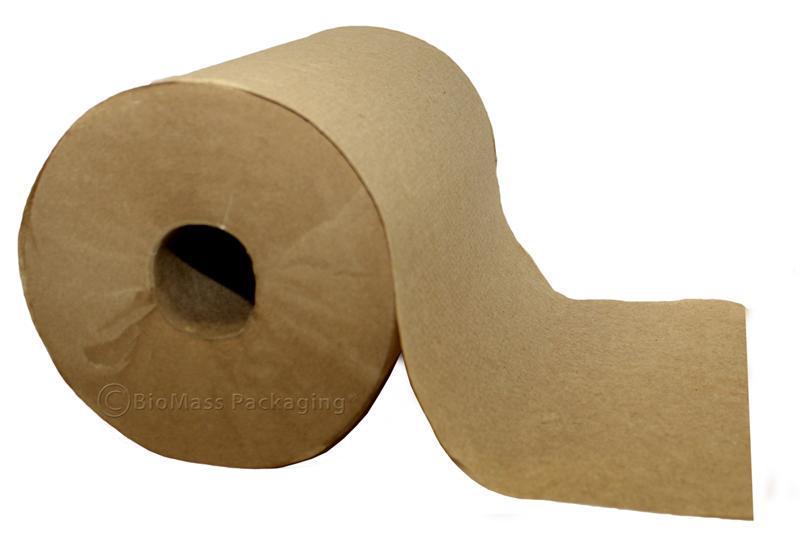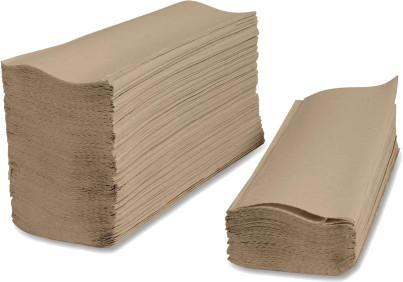The first image is the image on the left, the second image is the image on the right. Considering the images on both sides, is "There is a folded paper towel on one of the images." valid? Answer yes or no. Yes. 